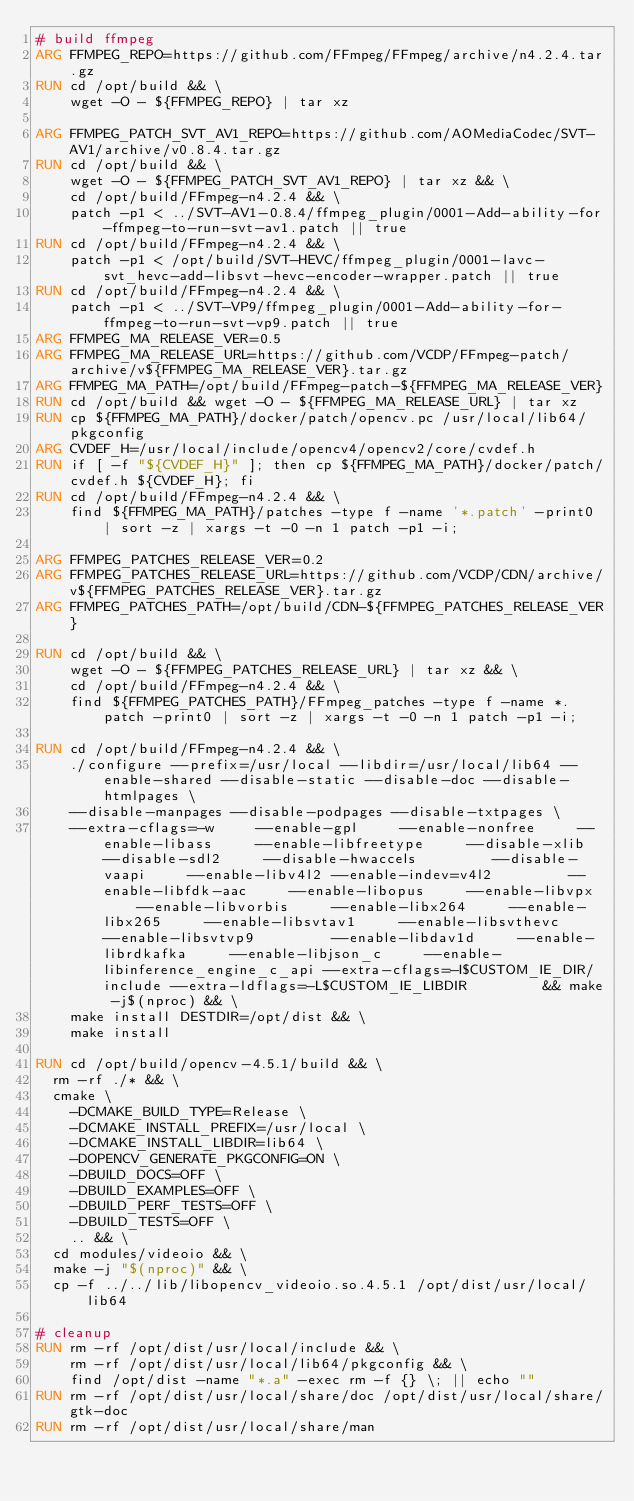Convert code to text. <code><loc_0><loc_0><loc_500><loc_500><_Dockerfile_># build ffmpeg
ARG FFMPEG_REPO=https://github.com/FFmpeg/FFmpeg/archive/n4.2.4.tar.gz
RUN cd /opt/build && \
    wget -O - ${FFMPEG_REPO} | tar xz

ARG FFMPEG_PATCH_SVT_AV1_REPO=https://github.com/AOMediaCodec/SVT-AV1/archive/v0.8.4.tar.gz
RUN cd /opt/build && \
    wget -O - ${FFMPEG_PATCH_SVT_AV1_REPO} | tar xz && \
    cd /opt/build/FFmpeg-n4.2.4 && \
    patch -p1 < ../SVT-AV1-0.8.4/ffmpeg_plugin/0001-Add-ability-for-ffmpeg-to-run-svt-av1.patch || true
RUN cd /opt/build/FFmpeg-n4.2.4 && \
    patch -p1 < /opt/build/SVT-HEVC/ffmpeg_plugin/0001-lavc-svt_hevc-add-libsvt-hevc-encoder-wrapper.patch || true
RUN cd /opt/build/FFmpeg-n4.2.4 && \
    patch -p1 < ../SVT-VP9/ffmpeg_plugin/0001-Add-ability-for-ffmpeg-to-run-svt-vp9.patch || true
ARG FFMPEG_MA_RELEASE_VER=0.5
ARG FFMPEG_MA_RELEASE_URL=https://github.com/VCDP/FFmpeg-patch/archive/v${FFMPEG_MA_RELEASE_VER}.tar.gz
ARG FFMPEG_MA_PATH=/opt/build/FFmpeg-patch-${FFMPEG_MA_RELEASE_VER}
RUN cd /opt/build && wget -O - ${FFMPEG_MA_RELEASE_URL} | tar xz
RUN cp ${FFMPEG_MA_PATH}/docker/patch/opencv.pc /usr/local/lib64/pkgconfig
ARG CVDEF_H=/usr/local/include/opencv4/opencv2/core/cvdef.h
RUN if [ -f "${CVDEF_H}" ]; then cp ${FFMPEG_MA_PATH}/docker/patch/cvdef.h ${CVDEF_H}; fi
RUN cd /opt/build/FFmpeg-n4.2.4 && \
    find ${FFMPEG_MA_PATH}/patches -type f -name '*.patch' -print0 | sort -z | xargs -t -0 -n 1 patch -p1 -i;

ARG FFMPEG_PATCHES_RELEASE_VER=0.2
ARG FFMPEG_PATCHES_RELEASE_URL=https://github.com/VCDP/CDN/archive/v${FFMPEG_PATCHES_RELEASE_VER}.tar.gz
ARG FFMPEG_PATCHES_PATH=/opt/build/CDN-${FFMPEG_PATCHES_RELEASE_VER}

RUN cd /opt/build && \
    wget -O - ${FFMPEG_PATCHES_RELEASE_URL} | tar xz && \
    cd /opt/build/FFmpeg-n4.2.4 && \
    find ${FFMPEG_PATCHES_PATH}/FFmpeg_patches -type f -name *.patch -print0 | sort -z | xargs -t -0 -n 1 patch -p1 -i;

RUN cd /opt/build/FFmpeg-n4.2.4 && \
    ./configure --prefix=/usr/local --libdir=/usr/local/lib64 --enable-shared --disable-static --disable-doc --disable-htmlpages \
    --disable-manpages --disable-podpages --disable-txtpages \
    --extra-cflags=-w     --enable-gpl     --enable-nonfree     --enable-libass     --enable-libfreetype     --disable-xlib --disable-sdl2     --disable-hwaccels         --disable-vaapi     --enable-libv4l2 --enable-indev=v4l2         --enable-libfdk-aac     --enable-libopus     --enable-libvpx     --enable-libvorbis     --enable-libx264     --enable-libx265     --enable-libsvtav1     --enable-libsvthevc     --enable-libsvtvp9         --enable-libdav1d     --enable-librdkafka     --enable-libjson_c     --enable-libinference_engine_c_api --extra-cflags=-I$CUSTOM_IE_DIR/include --extra-ldflags=-L$CUSTOM_IE_LIBDIR         && make -j$(nproc) && \
    make install DESTDIR=/opt/dist && \
    make install

RUN cd /opt/build/opencv-4.5.1/build && \
  rm -rf ./* && \
  cmake \
    -DCMAKE_BUILD_TYPE=Release \
    -DCMAKE_INSTALL_PREFIX=/usr/local \
    -DCMAKE_INSTALL_LIBDIR=lib64 \
    -DOPENCV_GENERATE_PKGCONFIG=ON \
    -DBUILD_DOCS=OFF \
    -DBUILD_EXAMPLES=OFF \
    -DBUILD_PERF_TESTS=OFF \
    -DBUILD_TESTS=OFF \
    .. && \
  cd modules/videoio && \
  make -j "$(nproc)" && \
  cp -f ../../lib/libopencv_videoio.so.4.5.1 /opt/dist/usr/local/lib64

# cleanup
RUN rm -rf /opt/dist/usr/local/include && \
    rm -rf /opt/dist/usr/local/lib64/pkgconfig && \
    find /opt/dist -name "*.a" -exec rm -f {} \; || echo ""
RUN rm -rf /opt/dist/usr/local/share/doc /opt/dist/usr/local/share/gtk-doc
RUN rm -rf /opt/dist/usr/local/share/man</code> 